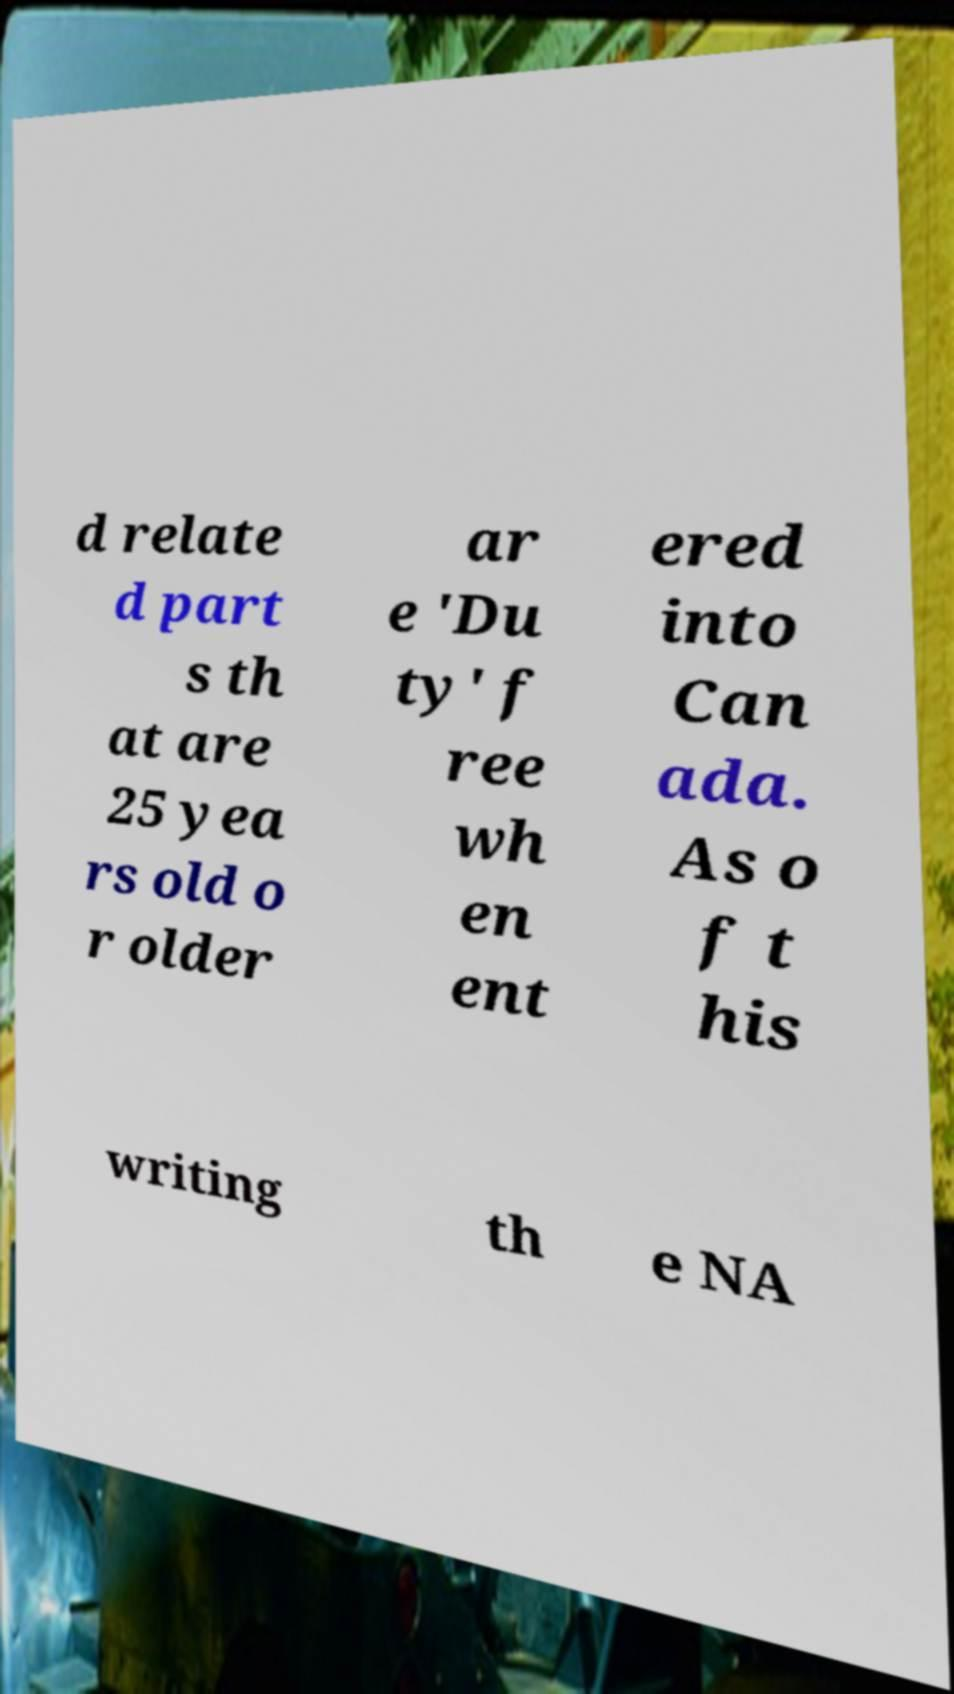Can you read and provide the text displayed in the image?This photo seems to have some interesting text. Can you extract and type it out for me? d relate d part s th at are 25 yea rs old o r older ar e 'Du ty' f ree wh en ent ered into Can ada. As o f t his writing th e NA 